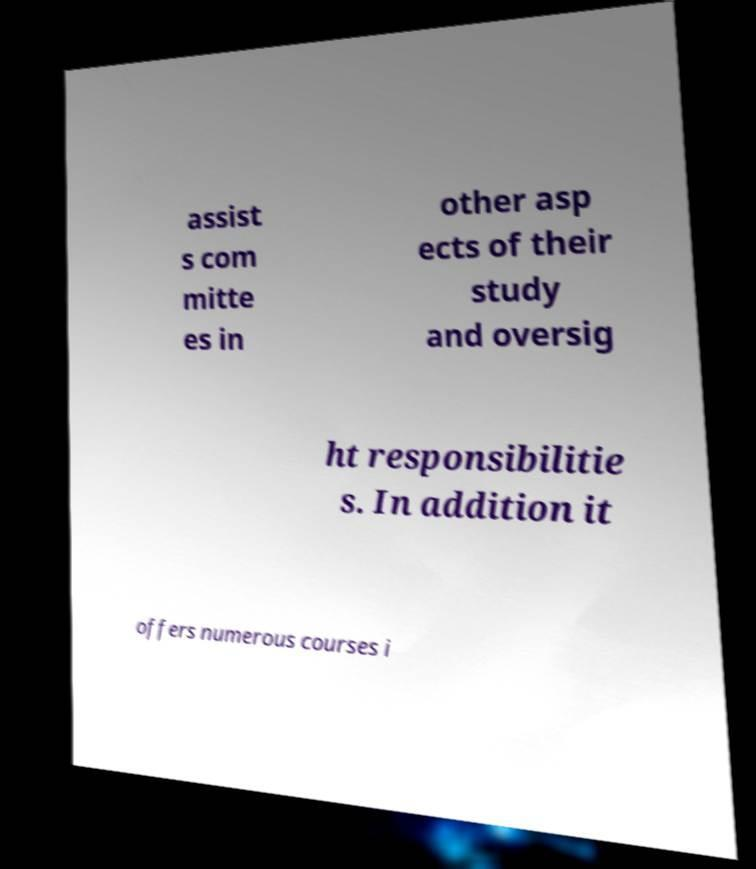Can you accurately transcribe the text from the provided image for me? assist s com mitte es in other asp ects of their study and oversig ht responsibilitie s. In addition it offers numerous courses i 